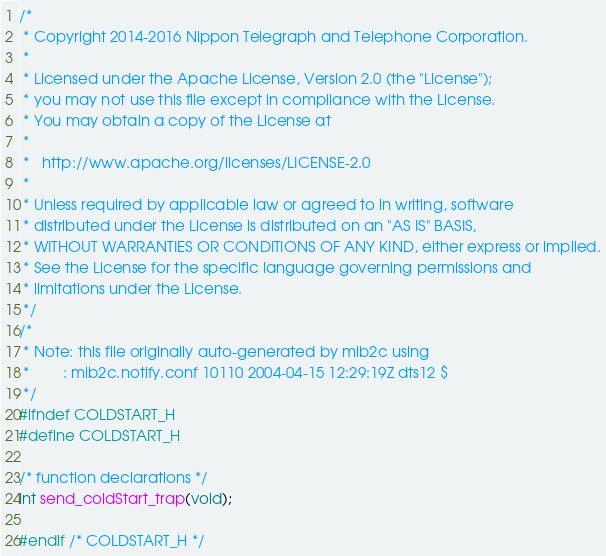<code> <loc_0><loc_0><loc_500><loc_500><_C_>/*
 * Copyright 2014-2016 Nippon Telegraph and Telephone Corporation.
 *
 * Licensed under the Apache License, Version 2.0 (the "License");
 * you may not use this file except in compliance with the License.
 * You may obtain a copy of the License at
 *
 *   http://www.apache.org/licenses/LICENSE-2.0
 *
 * Unless required by applicable law or agreed to in writing, software
 * distributed under the License is distributed on an "AS IS" BASIS,
 * WITHOUT WARRANTIES OR CONDITIONS OF ANY KIND, either express or implied.
 * See the License for the specific language governing permissions and
 * limitations under the License.
 */
/*
 * Note: this file originally auto-generated by mib2c using
 *        : mib2c.notify.conf 10110 2004-04-15 12:29:19Z dts12 $
 */
#ifndef COLDSTART_H
#define COLDSTART_H

/* function declarations */
int send_coldStart_trap(void);

#endif /* COLDSTART_H */
</code> 